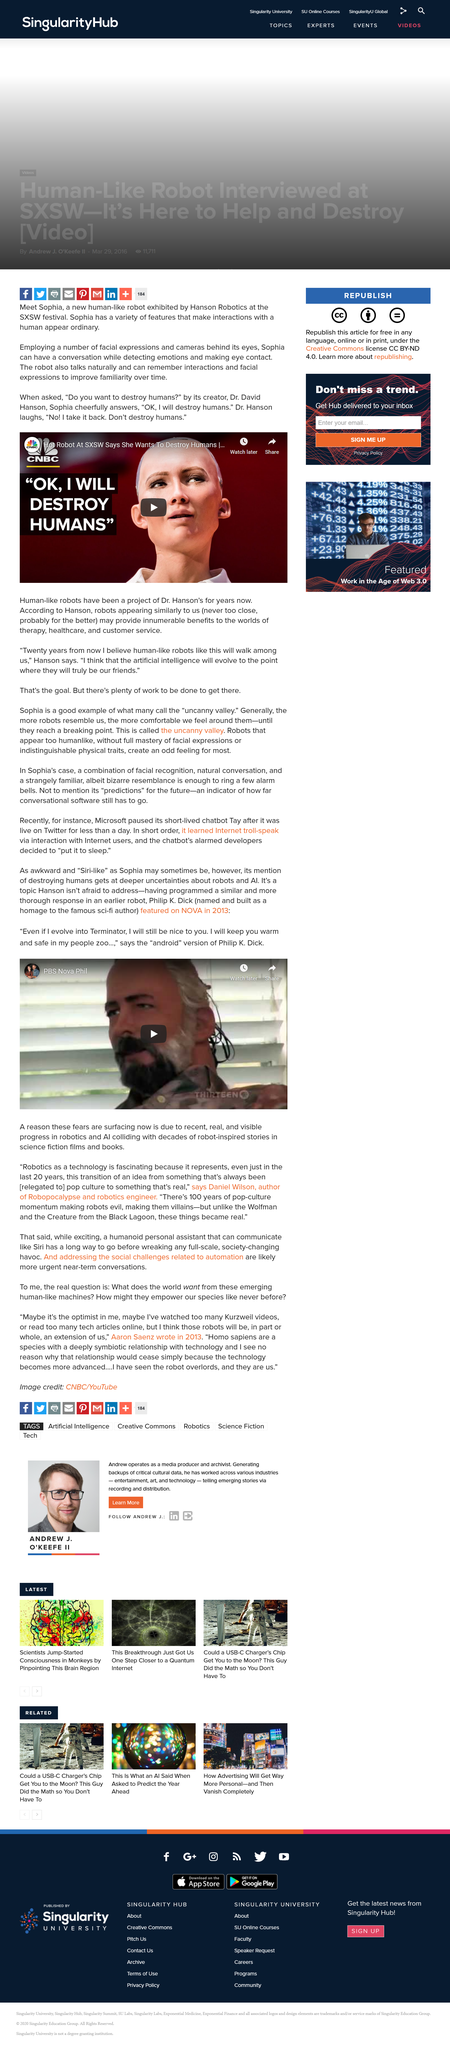List a handful of essential elements in this visual. In 2013, a robot modeled on a famous science-fiction author was featured on the television program NOVA. Microsoft's short-lived chatbot was named Tay. The name of the Human-like robot is Sophia. Hason Robotics designed and created a new Human-like robot that is widely recognized as a cutting-edge technological achievement. The article highlights deeper uncertainties regarding robots and artificial intelligence (AI). 